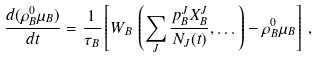<formula> <loc_0><loc_0><loc_500><loc_500>\frac { d ( \rho _ { B } ^ { 0 } \mu _ { B } ) } { d t } = \frac { 1 } { \tau _ { B } } \left [ W _ { B } \, \left ( \sum _ { J } \frac { p _ { B } ^ { J } X _ { B } ^ { J } } { N _ { J } ( t ) } , \dots \right ) - \rho _ { B } ^ { 0 } \mu _ { B } \right ] \, ,</formula> 